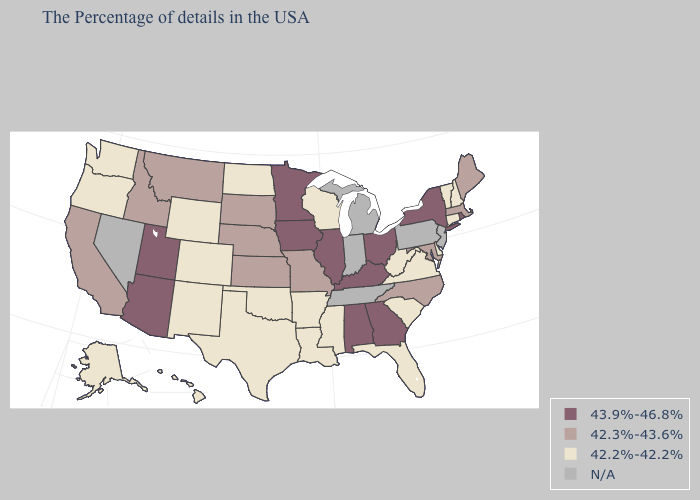Name the states that have a value in the range 42.2%-42.2%?
Quick response, please. New Hampshire, Vermont, Connecticut, Delaware, Virginia, South Carolina, West Virginia, Florida, Wisconsin, Mississippi, Louisiana, Arkansas, Oklahoma, Texas, North Dakota, Wyoming, Colorado, New Mexico, Washington, Oregon, Alaska, Hawaii. Among the states that border Wyoming , does Utah have the highest value?
Write a very short answer. Yes. Which states have the highest value in the USA?
Keep it brief. Rhode Island, New York, Ohio, Georgia, Kentucky, Alabama, Illinois, Minnesota, Iowa, Utah, Arizona. Name the states that have a value in the range 42.2%-42.2%?
Write a very short answer. New Hampshire, Vermont, Connecticut, Delaware, Virginia, South Carolina, West Virginia, Florida, Wisconsin, Mississippi, Louisiana, Arkansas, Oklahoma, Texas, North Dakota, Wyoming, Colorado, New Mexico, Washington, Oregon, Alaska, Hawaii. Name the states that have a value in the range 42.2%-42.2%?
Keep it brief. New Hampshire, Vermont, Connecticut, Delaware, Virginia, South Carolina, West Virginia, Florida, Wisconsin, Mississippi, Louisiana, Arkansas, Oklahoma, Texas, North Dakota, Wyoming, Colorado, New Mexico, Washington, Oregon, Alaska, Hawaii. Does Alaska have the lowest value in the West?
Be succinct. Yes. What is the lowest value in the USA?
Be succinct. 42.2%-42.2%. What is the lowest value in the MidWest?
Quick response, please. 42.2%-42.2%. Does Georgia have the highest value in the USA?
Keep it brief. Yes. Among the states that border South Dakota , which have the lowest value?
Quick response, please. North Dakota, Wyoming. What is the highest value in the USA?
Be succinct. 43.9%-46.8%. Is the legend a continuous bar?
Quick response, please. No. How many symbols are there in the legend?
Keep it brief. 4. 